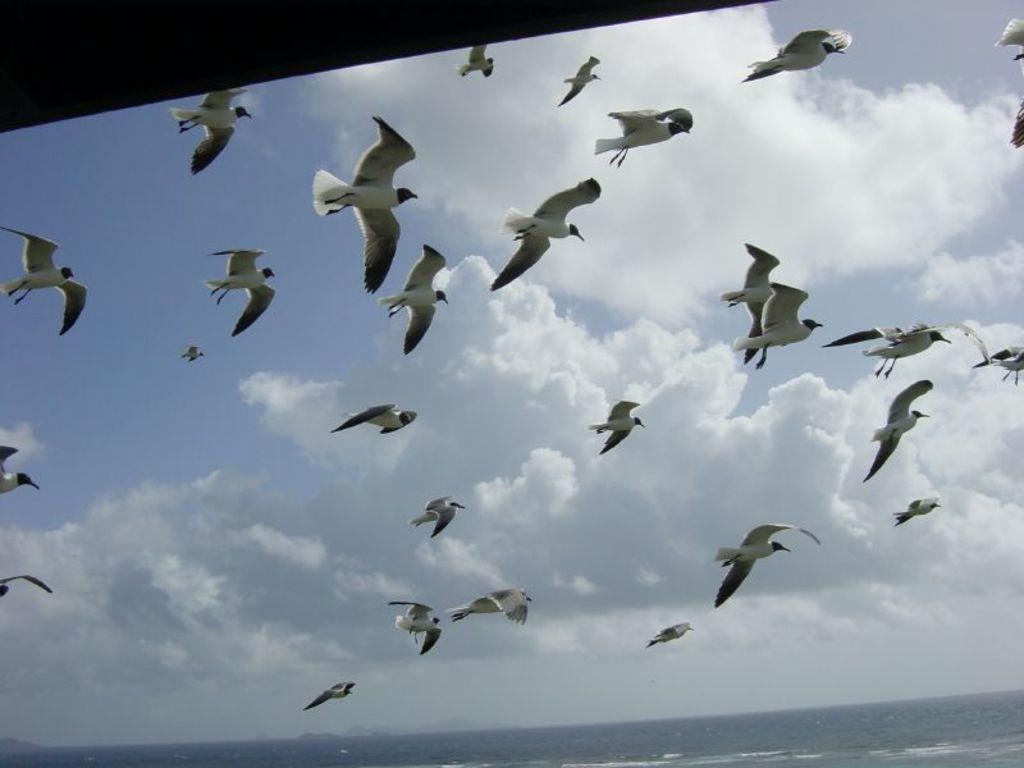What type of animals can be seen in the image? There are birds in the image. Where are the birds located in the image? The birds are in the sky. Can you describe the position of the birds in the image? The birds are in the center of the image. What type of bun is being held by the father in the image? There is no father or bun present in the image; it features birds in the sky. 